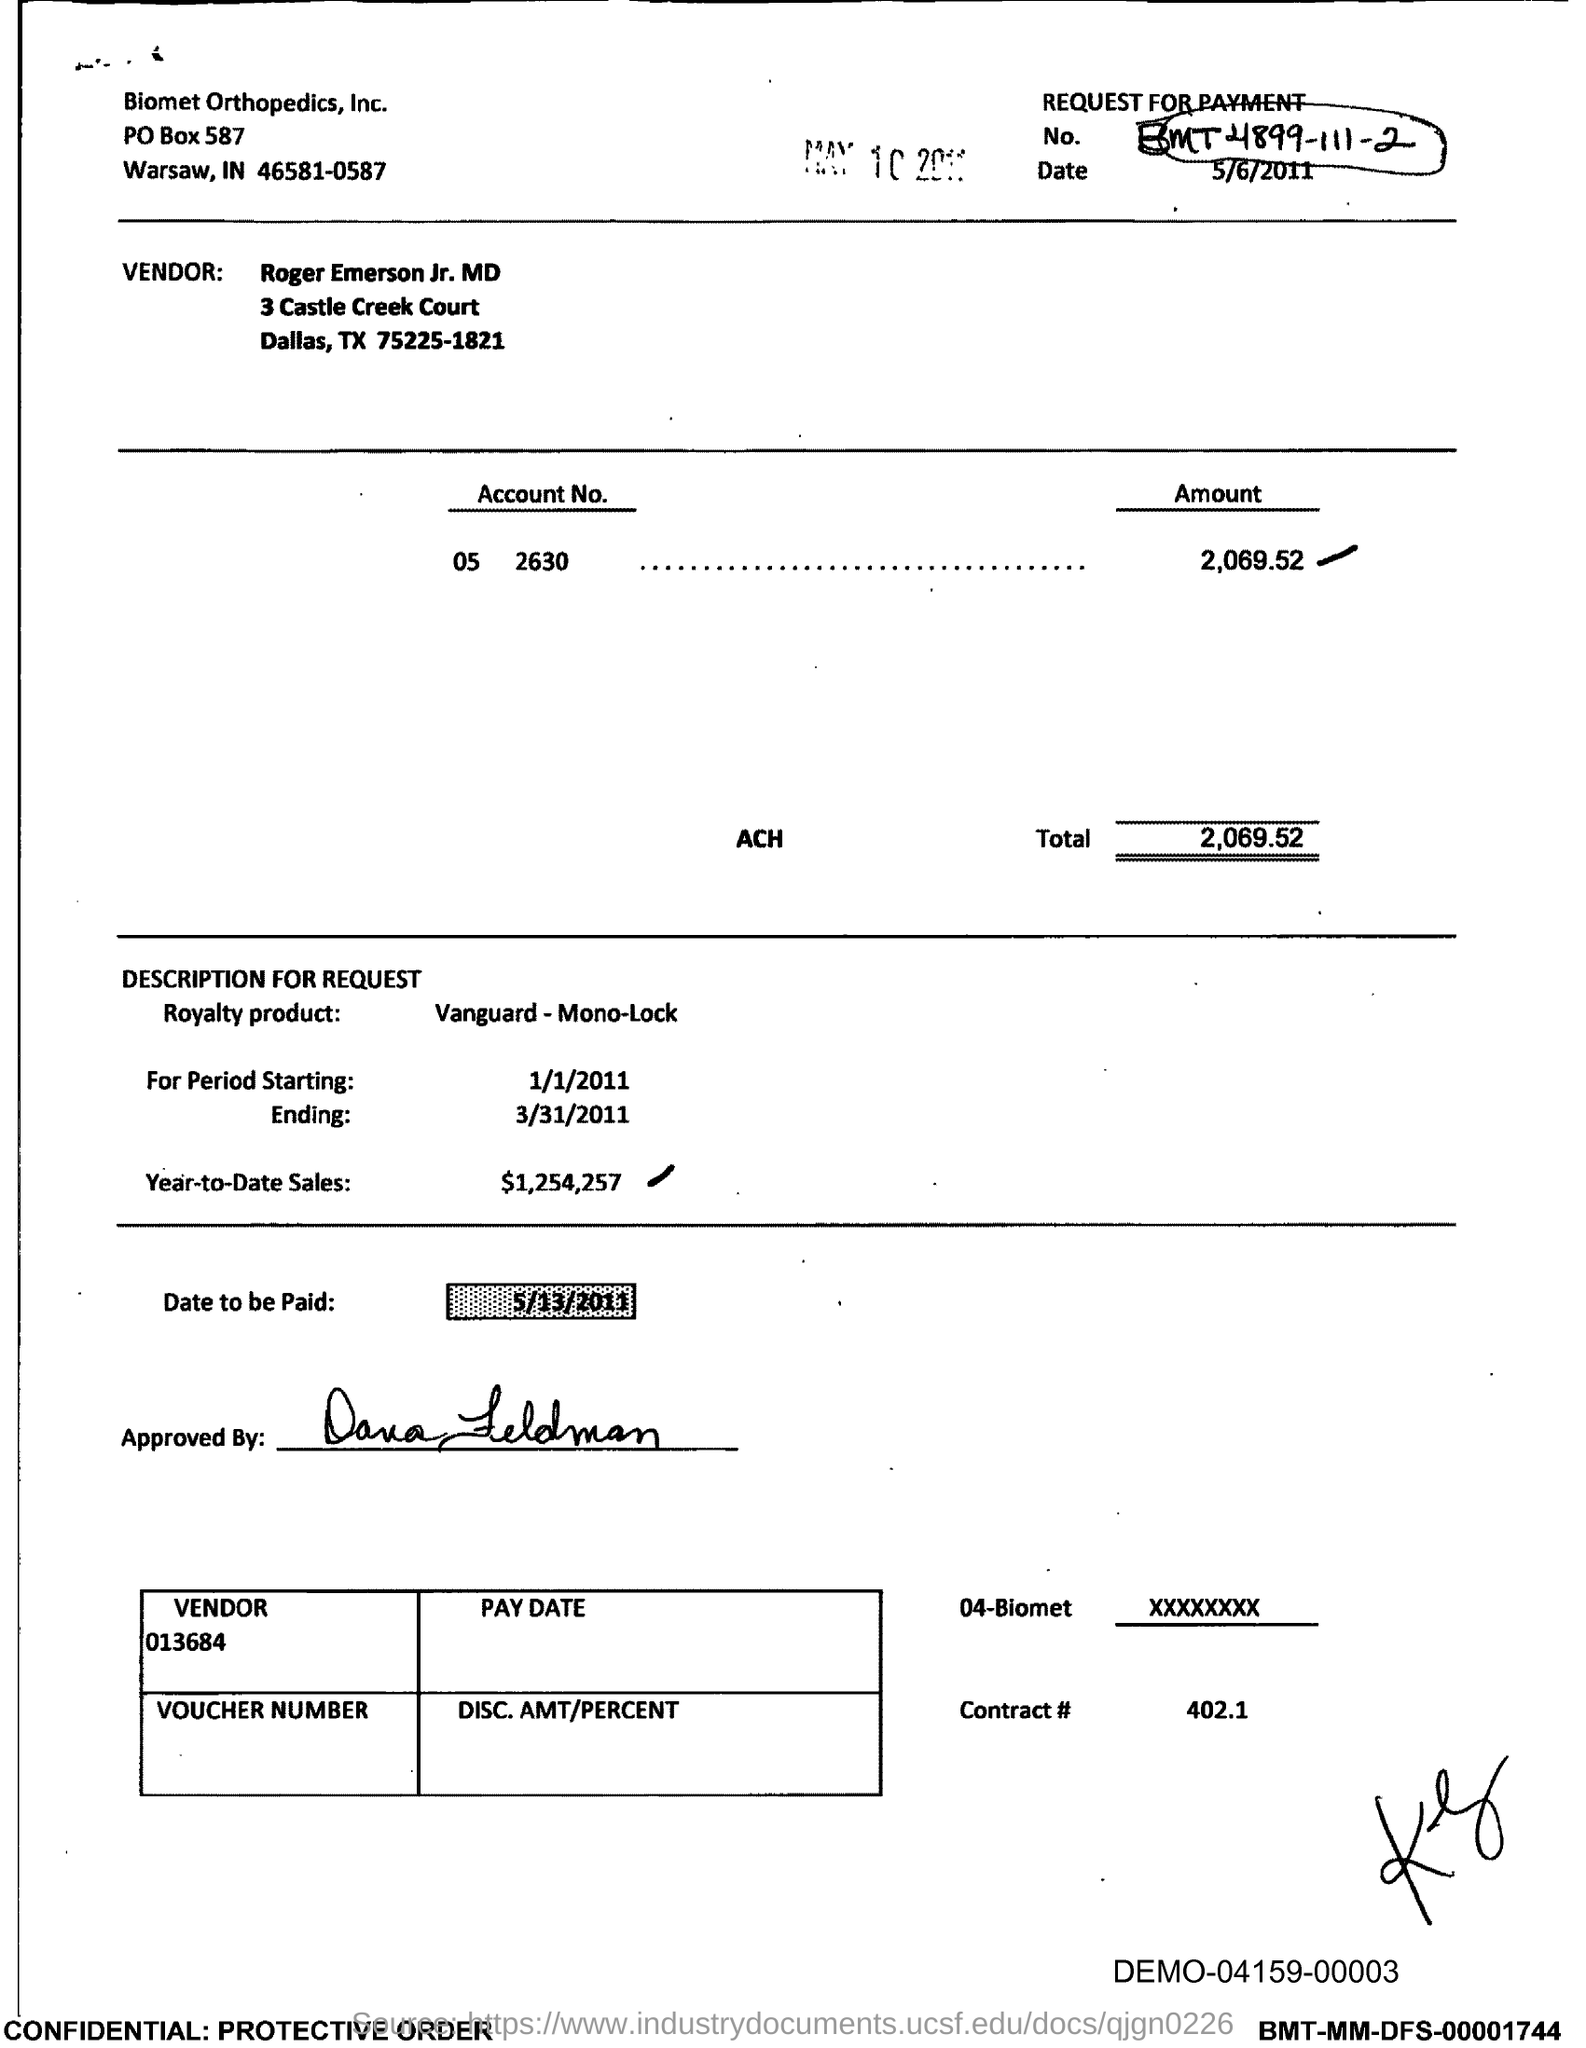List a handful of essential elements in this visual. I'm sorry, I'm not sure what document you are referring to. Could you please provide more context or information about the contract number you are looking for? The total amount to be paid is 2,069.52. The year-to-date sales of the royalty product are $1,254,257. The document contains a request for payment with the number BMT4899-111-2.... The vendor mentioned in the document is Roger Emerson Jr., MD. 